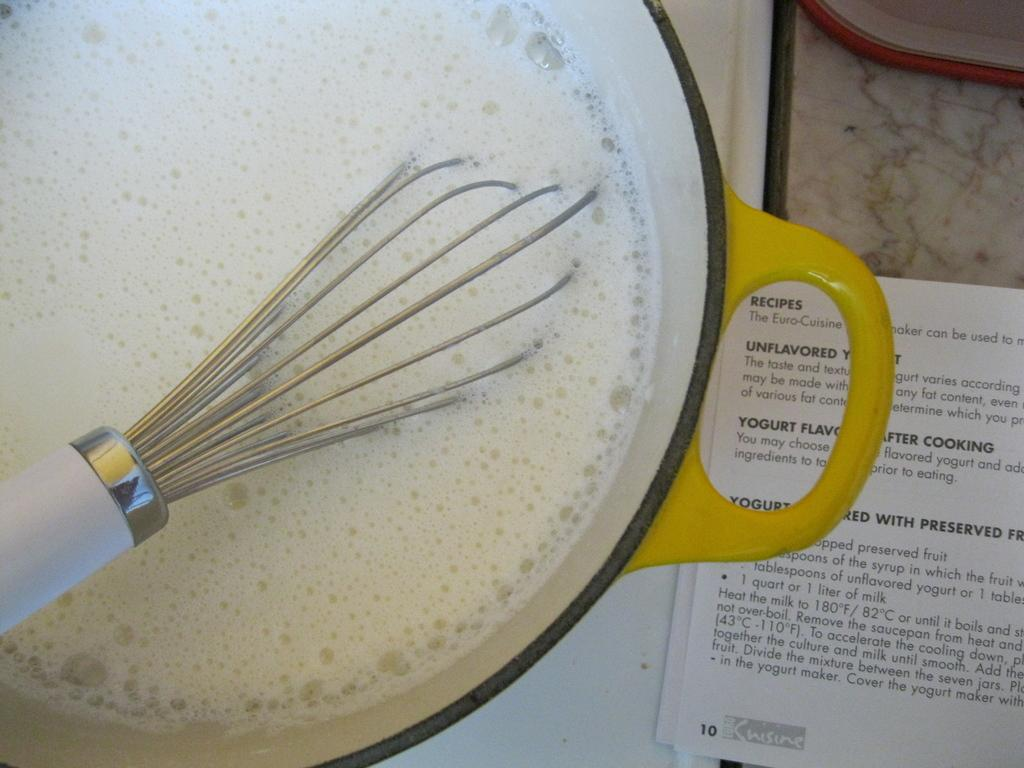What is present in the image that can hold a substance? There is a bowl in the image that can hold a substance. What is the color of the liquid in the bowl? The liquid in the bowl is white in color. What is used to mix or stir the liquid in the bowl? There is a churner in the bowl that is used to mix or stir the liquid. What can be seen on the right side of the image? There is a paper on the right side of the image. What type of cow can be seen grazing on the paper in the image? There is no cow present in the image, and the paper is not being grazed on by any animal. 